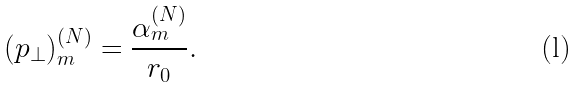Convert formula to latex. <formula><loc_0><loc_0><loc_500><loc_500>\left ( p _ { \bot } \right ) _ { m } ^ { ( N ) } = \frac { \alpha _ { m } ^ { ( N ) } } { r _ { 0 } } . \</formula> 